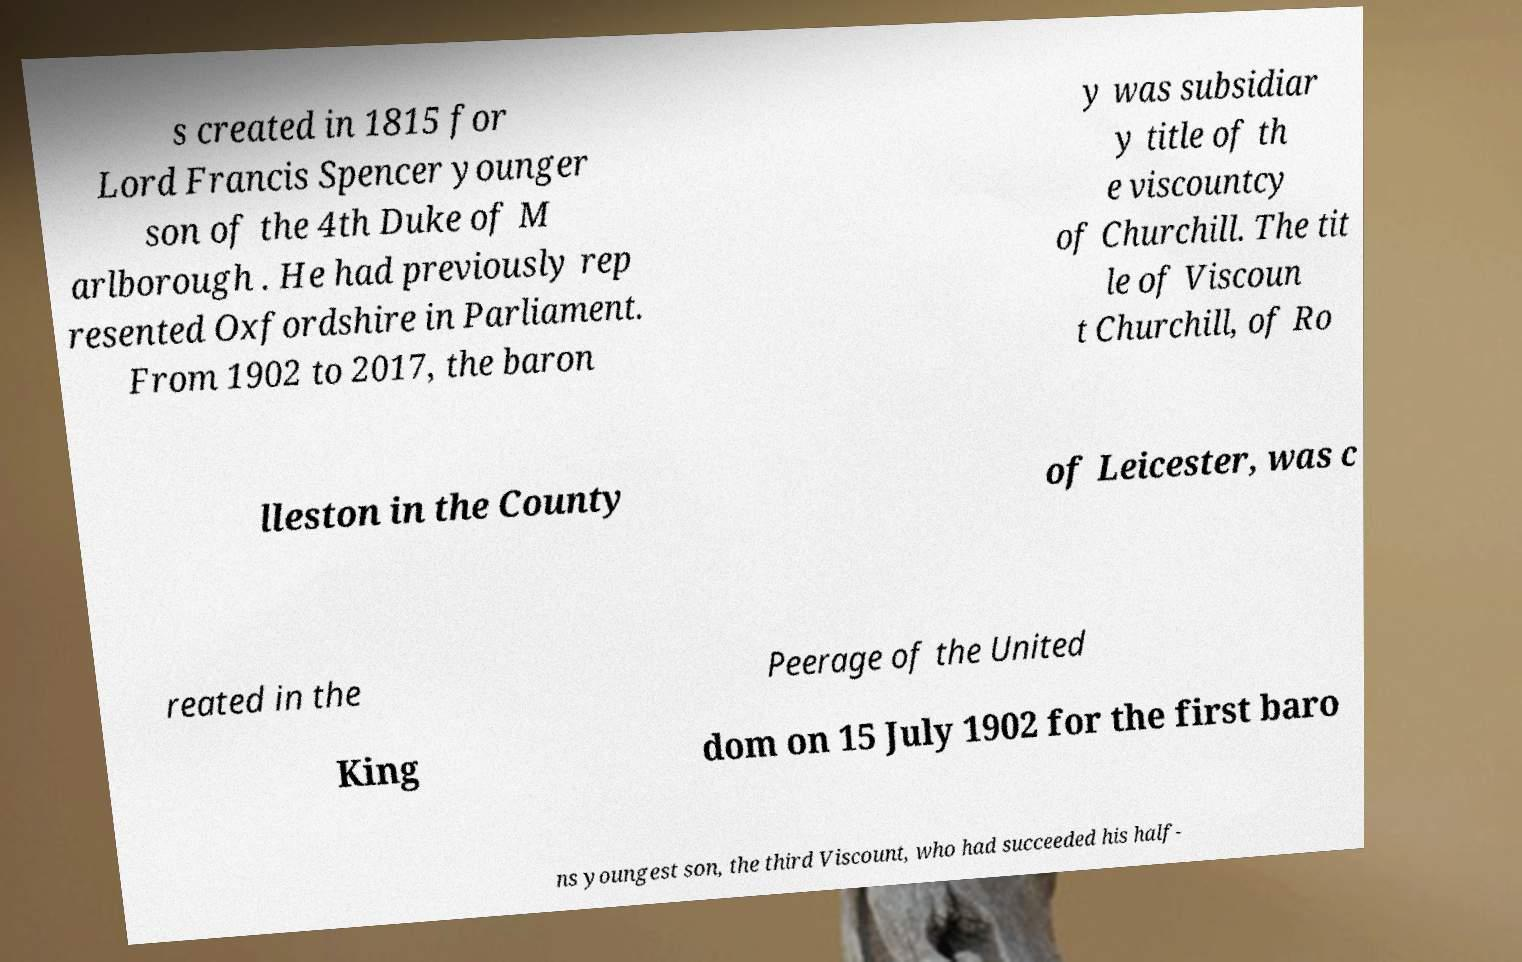Could you extract and type out the text from this image? s created in 1815 for Lord Francis Spencer younger son of the 4th Duke of M arlborough . He had previously rep resented Oxfordshire in Parliament. From 1902 to 2017, the baron y was subsidiar y title of th e viscountcy of Churchill. The tit le of Viscoun t Churchill, of Ro lleston in the County of Leicester, was c reated in the Peerage of the United King dom on 15 July 1902 for the first baro ns youngest son, the third Viscount, who had succeeded his half- 